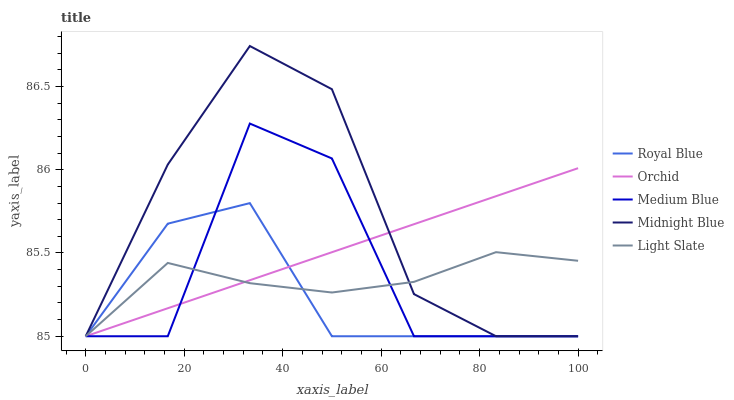Does Royal Blue have the minimum area under the curve?
Answer yes or no. Yes. Does Midnight Blue have the maximum area under the curve?
Answer yes or no. Yes. Does Medium Blue have the minimum area under the curve?
Answer yes or no. No. Does Medium Blue have the maximum area under the curve?
Answer yes or no. No. Is Orchid the smoothest?
Answer yes or no. Yes. Is Medium Blue the roughest?
Answer yes or no. Yes. Is Royal Blue the smoothest?
Answer yes or no. No. Is Royal Blue the roughest?
Answer yes or no. No. Does Light Slate have the lowest value?
Answer yes or no. Yes. Does Midnight Blue have the highest value?
Answer yes or no. Yes. Does Royal Blue have the highest value?
Answer yes or no. No. Does Medium Blue intersect Light Slate?
Answer yes or no. Yes. Is Medium Blue less than Light Slate?
Answer yes or no. No. Is Medium Blue greater than Light Slate?
Answer yes or no. No. 